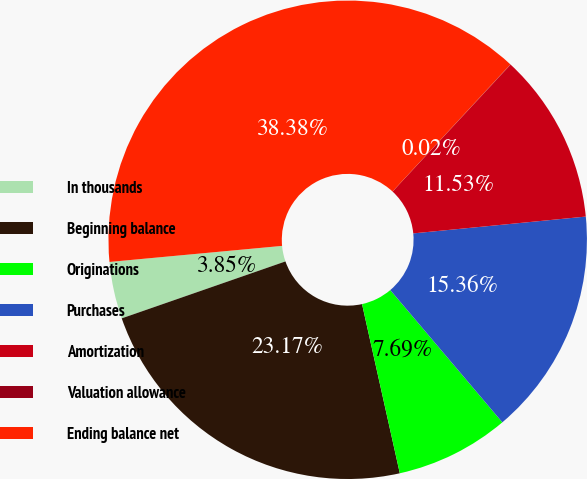Convert chart to OTSL. <chart><loc_0><loc_0><loc_500><loc_500><pie_chart><fcel>In thousands<fcel>Beginning balance<fcel>Originations<fcel>Purchases<fcel>Amortization<fcel>Valuation allowance<fcel>Ending balance net<nl><fcel>3.85%<fcel>23.17%<fcel>7.69%<fcel>15.36%<fcel>11.53%<fcel>0.02%<fcel>38.38%<nl></chart> 